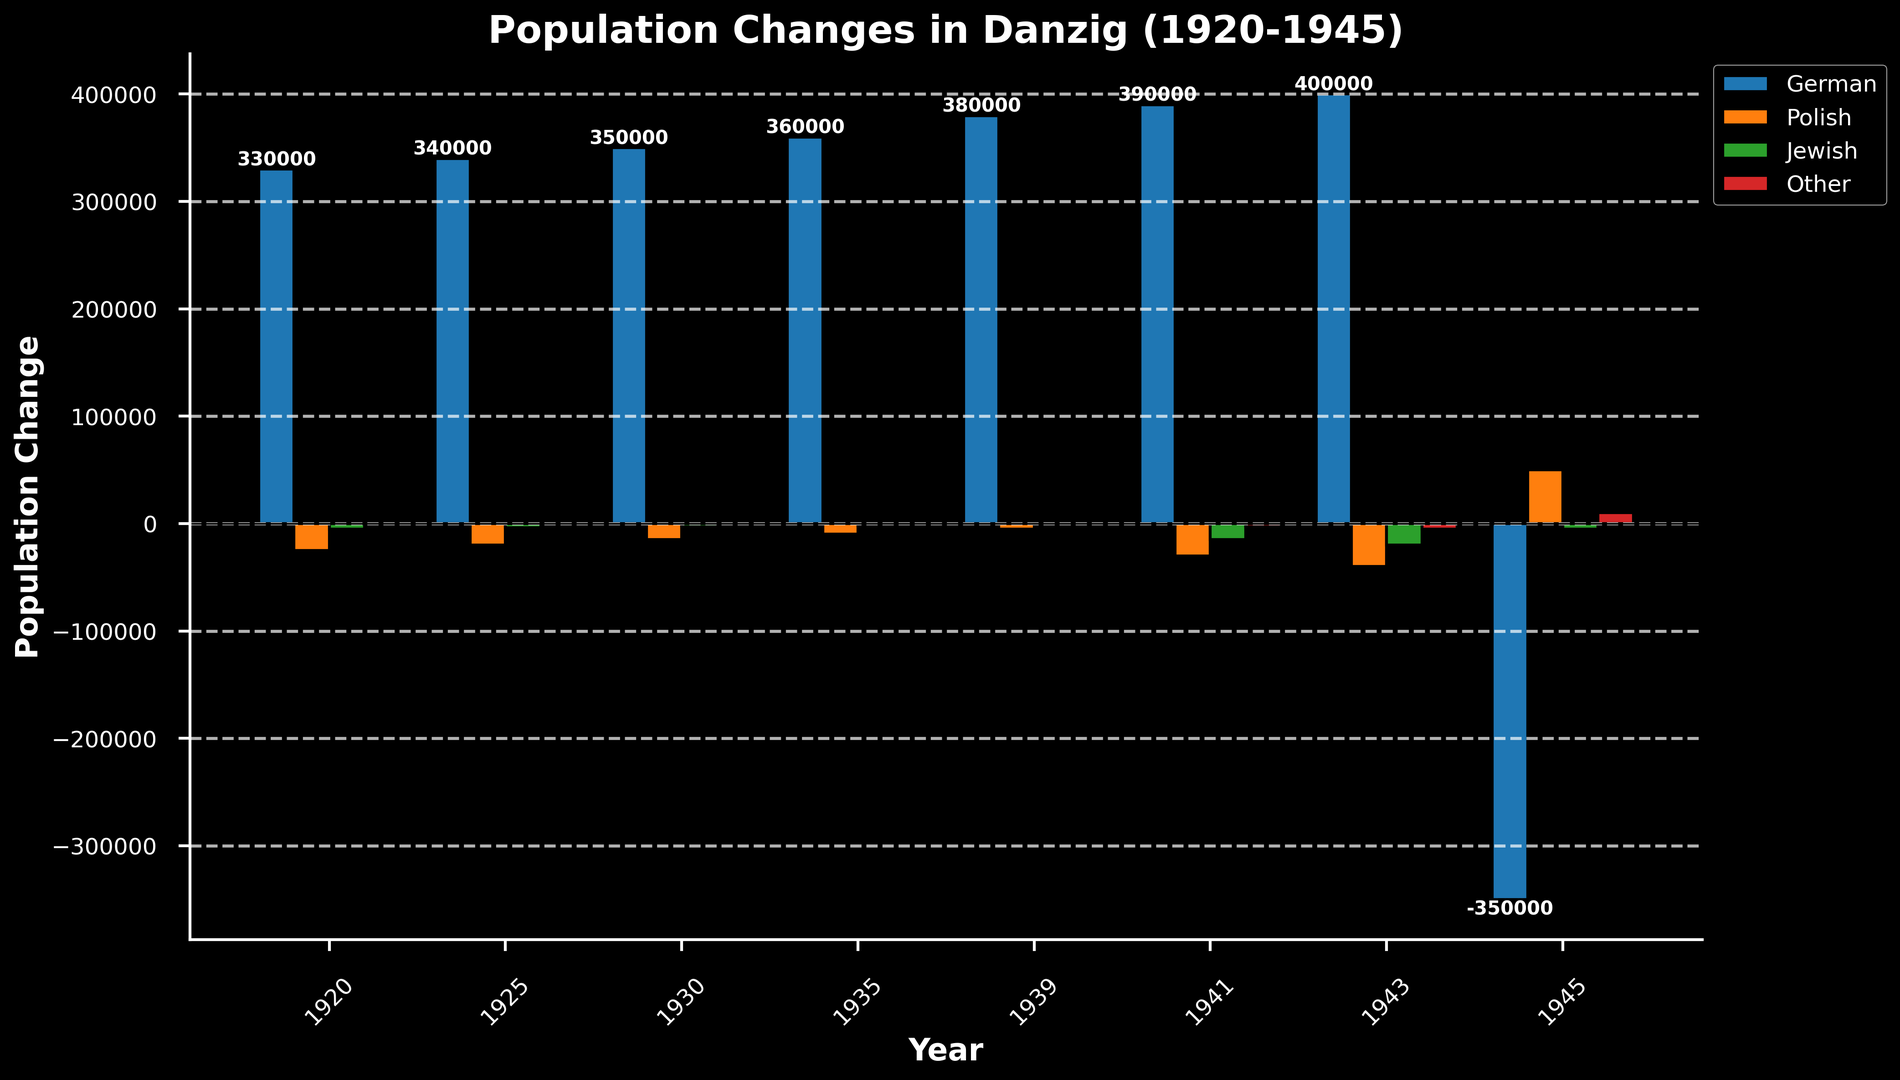What is the net population change for Germans in 1945? The bar for Germans in 1945 shows a negative value of -350,000. The net population change is -350,000.
Answer: -350,000 Which ethnic group experienced the largest positive population change in 1945? By visual inspection, the Polish bar for 1945 is the highest among the positive values.
Answer: Polish What is the sum of population changes for the Jewish group between 1920 and 1945? Sum the values for the Jewish group: -5000 + (-4000) + (-3000) + (-2000) + (-1000) + (-15000) + (-20000) + (-5000) = -54,000.
Answer: -54,000 Which year saw the largest decrease in the population of the Polish group? The largest negative bar for the Polish group is in 1943, with -40,000.
Answer: 1943 What is the difference in the population change of the "Other" group between 1945 and 1920? Subtract the 1920 value from the 1945 value for the "Other" group: 10,000 - (-2,000) = 12,000.
Answer: 12,000 Compare the population changes of the German group for 1925 and 1930. Which year has a higher change? The bar for 1930 (350,000) is higher than the bar for 1925 (340,000). Thus, 1930 has a higher change.
Answer: 1930 By how much did the population of the Polish group change from 1941 to 1943? Subtract the 1941 value from the 1943 value for the Polish group: -40,000 - (-30,000) = -10,000.
Answer: -10,000 Which ethnic group has the lowest population change in 1939? By visual inspection, the Jewish group bar in 1939 is the smallest, which is -1,000.
Answer: Jewish What is the average population change for the German group over the entire period shown? Add all values for the German group: 330,000 + 340,000 + 350,000 + 360,000 + 380,000 + 390,000 + 400,000 + (-350,000) = 2,200,000. Divide by the number of years (8): 2,200,000 / 8 = 275,000.
Answer: 275,000 In which year did the "Other" group experience a population increase, and by how much? In 1935 and 1939, the bars for "Other" show a positive increase. The increases are 1,000 (1935) and 2,000 (1939).
Answer: 1935 (1,000) and 1939 (2,000) 